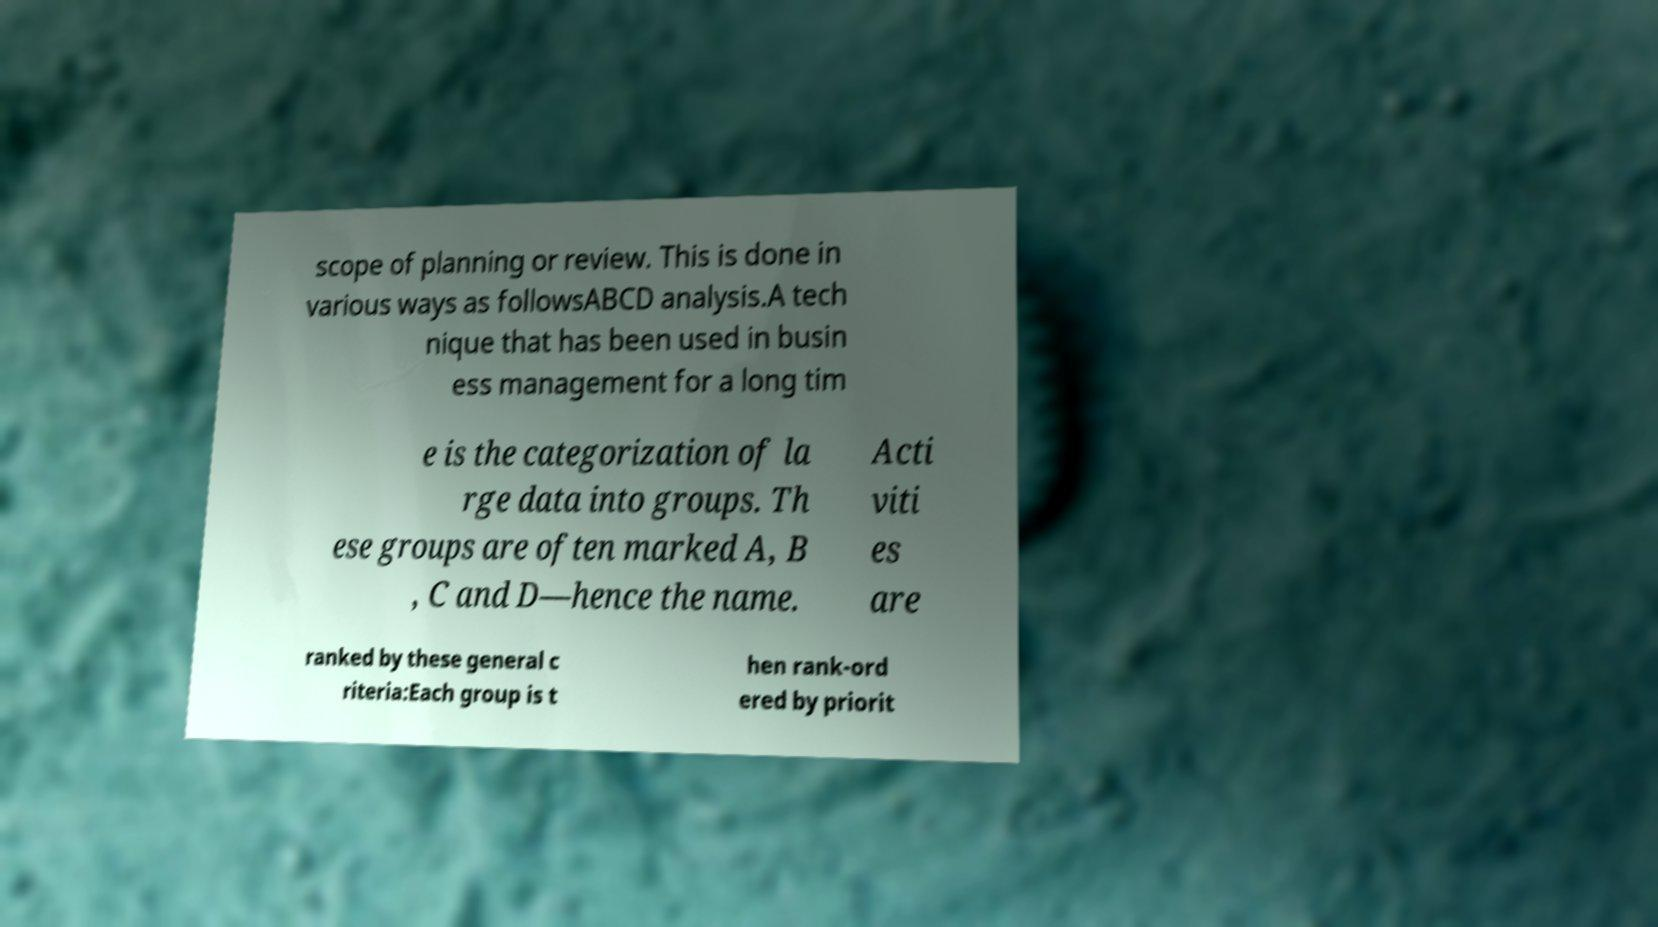What messages or text are displayed in this image? I need them in a readable, typed format. scope of planning or review. This is done in various ways as followsABCD analysis.A tech nique that has been used in busin ess management for a long tim e is the categorization of la rge data into groups. Th ese groups are often marked A, B , C and D—hence the name. Acti viti es are ranked by these general c riteria:Each group is t hen rank-ord ered by priorit 